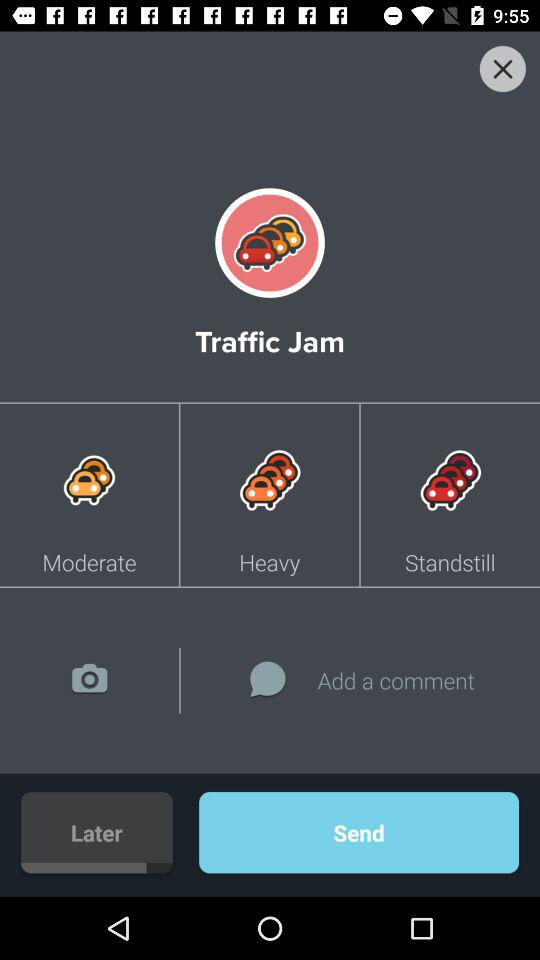What's the application name? The application name is "Traffic Jam". 